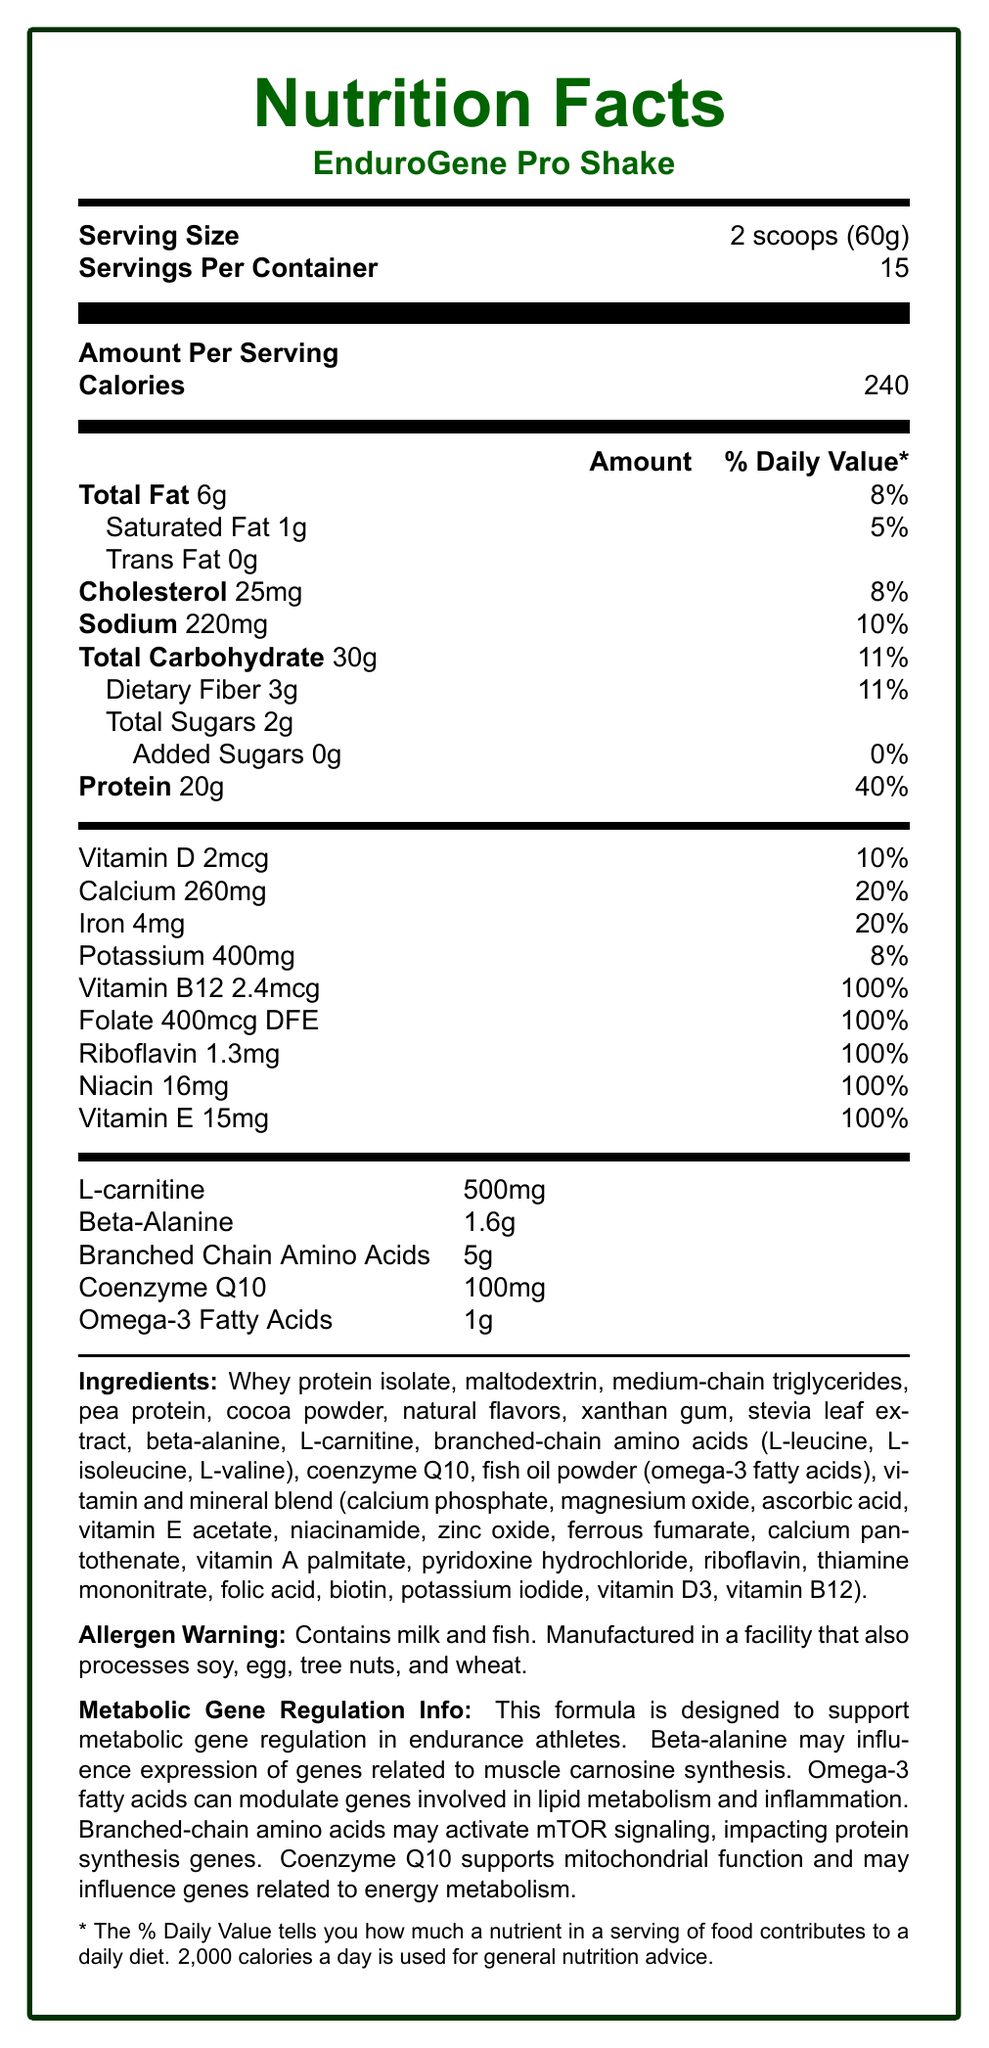what is the serving size of EnduroGene Pro Shake? The document states that the serving size is 2 scoops (60g).
Answer: 2 scoops (60g) how many calories are in one serving of EnduroGene Pro Shake? The document specifies that one serving contains 240 calories.
Answer: 240 calories what is the percentage of Daily Value for Vitamin D in one serving? According to the document, Vitamin D provides 10% of the Daily Value per serving.
Answer: 10% which nutrient has the highest Daily Value percentage per serving? The document indicates that Vitamin B12, Folate, Riboflavin, Niacin, and Vitamin E each have a 100% Daily Value per serving.
Answer: Vitamin B12/Folate/Riboflavin/Niacin/Vitamin E (all 100%) what are the main protein sources listed in the ingredients? The ingredients list mentions whey protein isolate and pea protein as the protein sources.
Answer: Whey protein isolate and pea protein how many servings are there per container? The document states there are 15 servings per container.
Answer: 15 servings does the EnduroGene Pro Shake contain any added sugars? The document specifies that there are 0g of added sugars in the shake.
Answer: No which of the following nutrients contributes to muscle carnosine synthesis? A. Omega-3 Fatty Acids B. Coenzyme Q10 C. Beta-Alanine D. L-Carnitine The document mentions Beta-Alanine as influencing the expression of genes related to muscle carnosine synthesis.
Answer: C. Beta-Alanine which vitamin is provided at 100% of the Daily Value but is not related to gene regulation as mentioned in the document? A. Vitamin B12 B. Vitamin E C. Folate D. Riboflavin Although Vitamin E provides 100% of the Daily Value, the document does not mention its relevance to gene regulation.
Answer: B. Vitamin E does the product contain any allergens? The document contains an allergen warning stating that the shake contains milk and fish.
Answer: Yes summarize the main idea of the Nutrition Facts Label for EnduroGene Pro Shake. The summary highlights the purpose of the shake, its nutrient content, and its role in metabolic gene regulation.
Answer: The EnduroGene Pro Shake is a meal replacement shake designed for endurance athletes, providing key nutrients like proteins, vitamins, and minerals. It includes specialized ingredients like beta-alanine, omega-3 fatty acids, and coenzyme Q10, which support metabolic gene regulation related to muscle synthesis, lipid metabolism, and energy production. The product contains 240 calories per serving with a balanced profile of fats, carbohydrates, and proteins, along with being fortified with numerous vitamins and minerals. what is the content of L-carnitine per serving? The document lists L-carnitine content as 500mg per serving.
Answer: 500mg what types of amino acids are included in the shake? The document mentions that the shake contains branched-chain amino acids, specifically L-leucine, L-isoleucine, and L-valine.
Answer: Branched-chain amino acids (L-leucine, L-isoleucine, L-valine) how does the omega-3 fatty acids influence gene expression, according to the document? The document states that omega-3 fatty acids modulate genes involved in lipid metabolism and inflammation.
Answer: They modulate genes involved in lipid metabolism and inflammation. what is the main function of coenzyme Q10 in the shake? The document states that coenzyme Q10 supports mitochondrial function and influences genes related to energy metabolism.
Answer: Supports mitochondrial function and influences genes related to energy metabolism. how do branched-chain amino acids (BCAAs) impact metabolic gene regulation? According to the document, branched-chain amino acids may activate mTOR signaling, which impacts protein synthesis genes.
Answer: BCAAs may activate mTOR signaling, impacting protein synthesis genes. how much protein is provided per serving as a percentage of the Daily Value? The document indicates that one serving provides 40% of the Daily Value for protein.
Answer: 40% what can you conclude about the total amount of sugars in one serving? The document specifies that each serving contains 2 grams of total sugars, with 0 grams of added sugars.
Answer: There are 2 grams of total sugars and no added sugars. how much potassium per serving as a percentage of the Daily Value is provided by the shake? The document lists that each serving supplies 8% of the Daily Value for potassium.
Answer: 8% who is the target demographic for EnduroGene Pro Shake? The product is designed for endurance athletes, as elucidated by its nutrient profile and metabolic gene regulation claims.
Answer: Endurance athletes what is the main purpose of the Nutritional Facts provided in the document? The document is intended to provide clear information on the specific nutrients and potential benefits of the shake for athletes, particularly in terms of metabolic gene regulation.
Answer: To inform potential consumers about the nutrient content and functional benefits of the EnduroGene Pro Shake. is the EnduroGene Pro Shake vegan? While the shake contains whey protein isolate and fish oil, it does not specify whether these are sourced in a way that would conform to vegan criteria.
Answer: Not enough information 